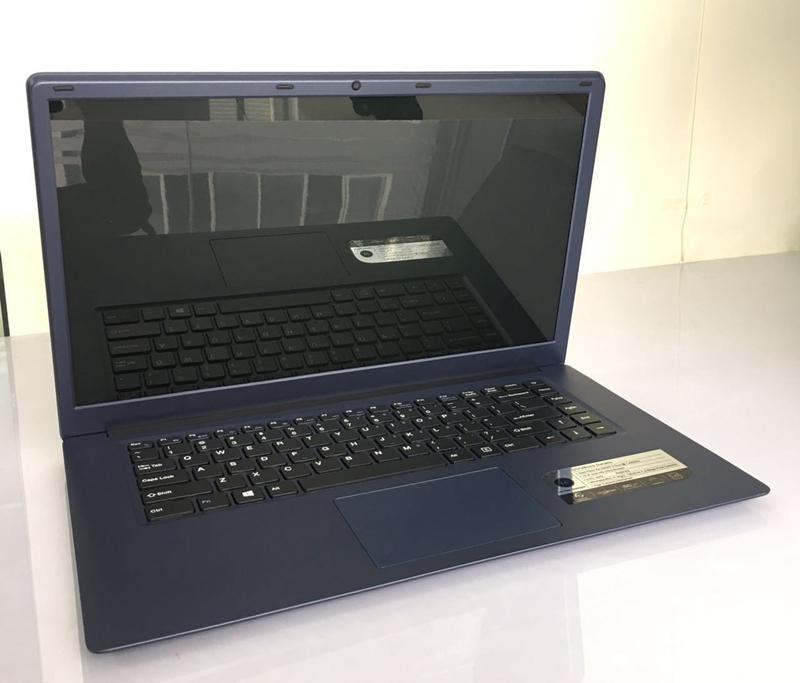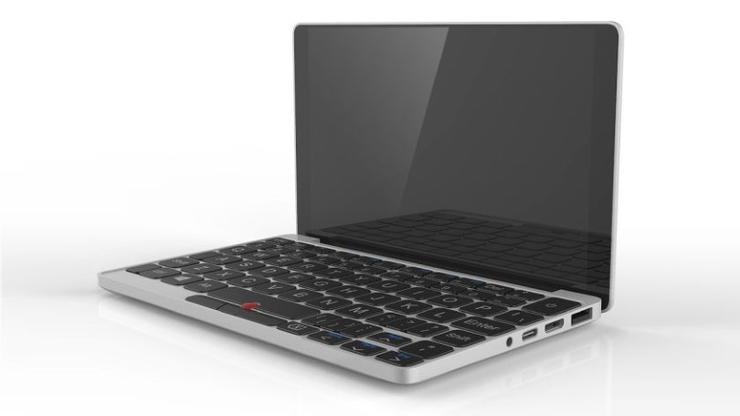The first image is the image on the left, the second image is the image on the right. For the images displayed, is the sentence "There are two laptops in one of the images." factually correct? Answer yes or no. No. The first image is the image on the left, the second image is the image on the right. Evaluate the accuracy of this statement regarding the images: "There are three computers". Is it true? Answer yes or no. No. 